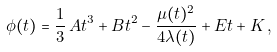Convert formula to latex. <formula><loc_0><loc_0><loc_500><loc_500>\phi ( t ) = \frac { 1 } { 3 } \, A t ^ { 3 } + B t ^ { 2 } - \frac { \mu ( t ) ^ { 2 } } { 4 \lambda ( t ) } + E t + K \, ,</formula> 